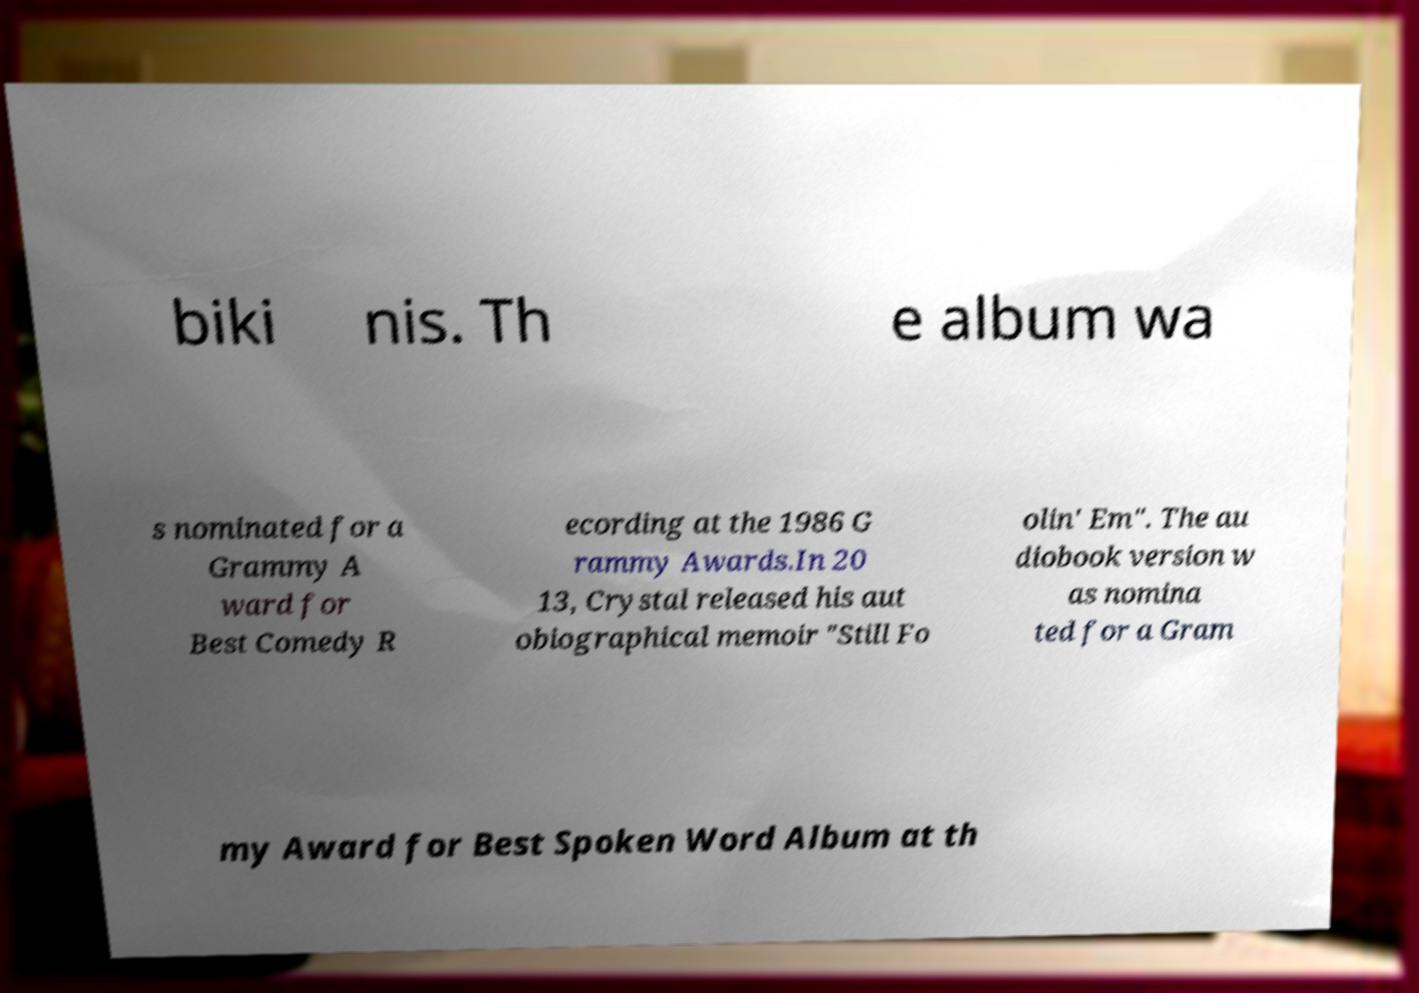I need the written content from this picture converted into text. Can you do that? biki nis. Th e album wa s nominated for a Grammy A ward for Best Comedy R ecording at the 1986 G rammy Awards.In 20 13, Crystal released his aut obiographical memoir "Still Fo olin' Em". The au diobook version w as nomina ted for a Gram my Award for Best Spoken Word Album at th 